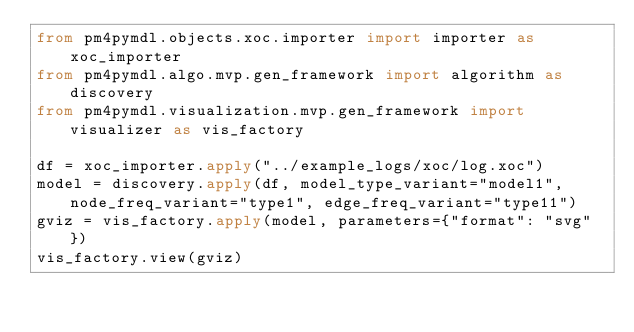Convert code to text. <code><loc_0><loc_0><loc_500><loc_500><_Python_>from pm4pymdl.objects.xoc.importer import importer as xoc_importer
from pm4pymdl.algo.mvp.gen_framework import algorithm as discovery
from pm4pymdl.visualization.mvp.gen_framework import visualizer as vis_factory

df = xoc_importer.apply("../example_logs/xoc/log.xoc")
model = discovery.apply(df, model_type_variant="model1", node_freq_variant="type1", edge_freq_variant="type11")
gviz = vis_factory.apply(model, parameters={"format": "svg"})
vis_factory.view(gviz)
</code> 